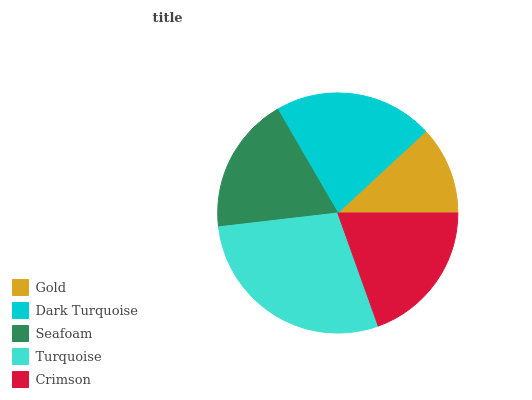Is Gold the minimum?
Answer yes or no. Yes. Is Turquoise the maximum?
Answer yes or no. Yes. Is Dark Turquoise the minimum?
Answer yes or no. No. Is Dark Turquoise the maximum?
Answer yes or no. No. Is Dark Turquoise greater than Gold?
Answer yes or no. Yes. Is Gold less than Dark Turquoise?
Answer yes or no. Yes. Is Gold greater than Dark Turquoise?
Answer yes or no. No. Is Dark Turquoise less than Gold?
Answer yes or no. No. Is Crimson the high median?
Answer yes or no. Yes. Is Crimson the low median?
Answer yes or no. Yes. Is Turquoise the high median?
Answer yes or no. No. Is Dark Turquoise the low median?
Answer yes or no. No. 